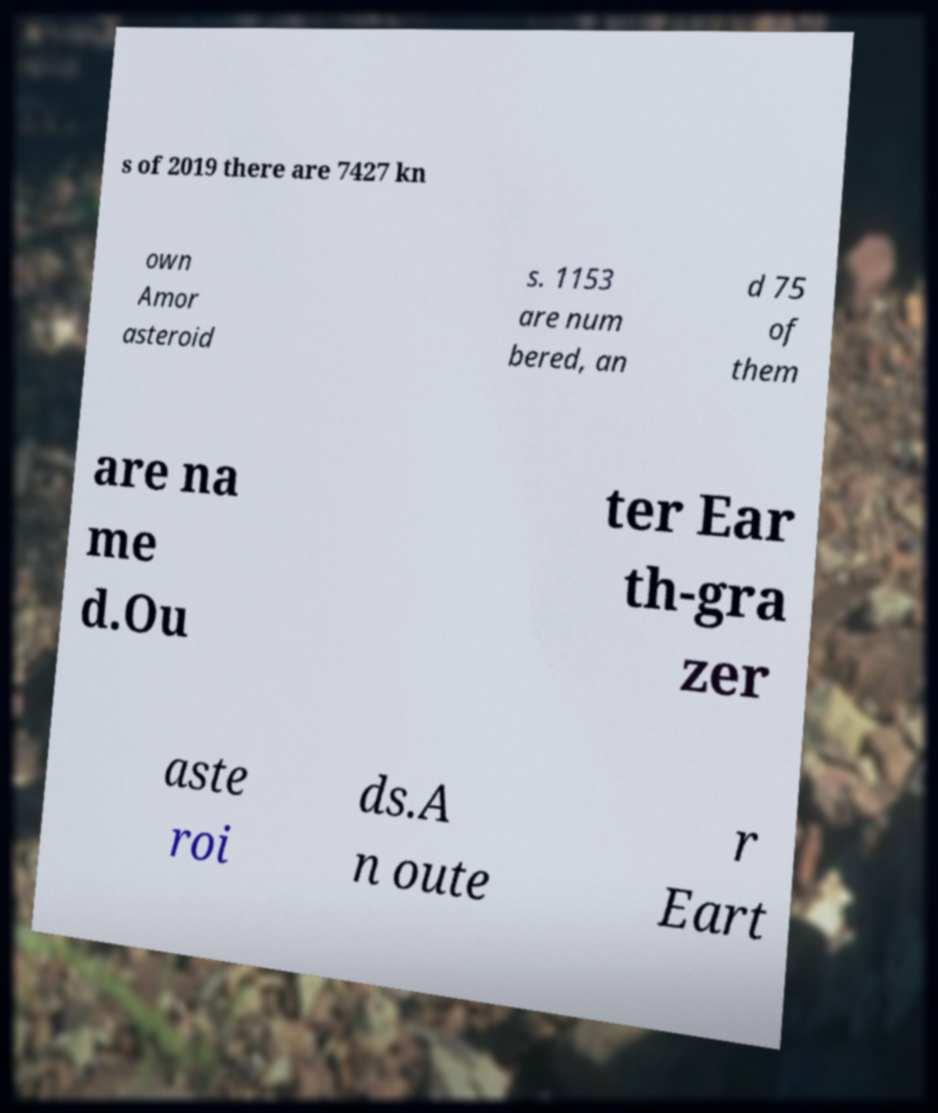Can you read and provide the text displayed in the image?This photo seems to have some interesting text. Can you extract and type it out for me? s of 2019 there are 7427 kn own Amor asteroid s. 1153 are num bered, an d 75 of them are na me d.Ou ter Ear th-gra zer aste roi ds.A n oute r Eart 